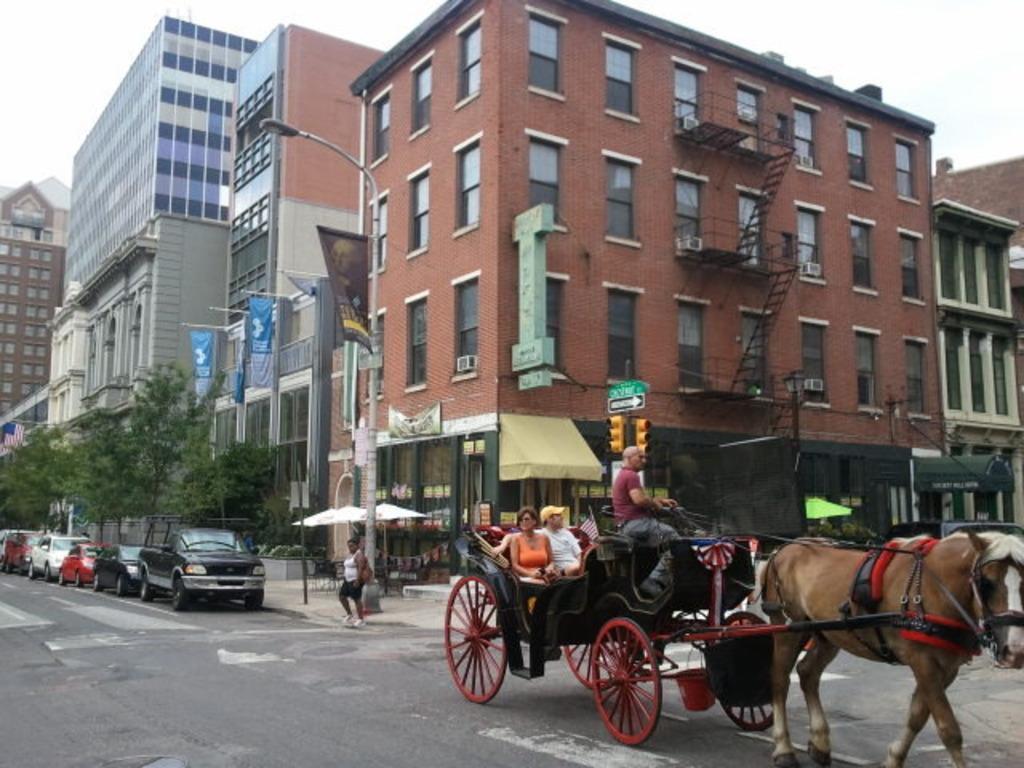In one or two sentences, can you explain what this image depicts? In this picture we can see there are three persons sitting on a horse cart. On the left side of the image, there are vehicles and a person on the road. Behind the vehicles, there are trees, banners, a flag, umbrellas, street lights buildings and the sky. Behind the cart, there is a pole with traffic signals and boards attached to it. 